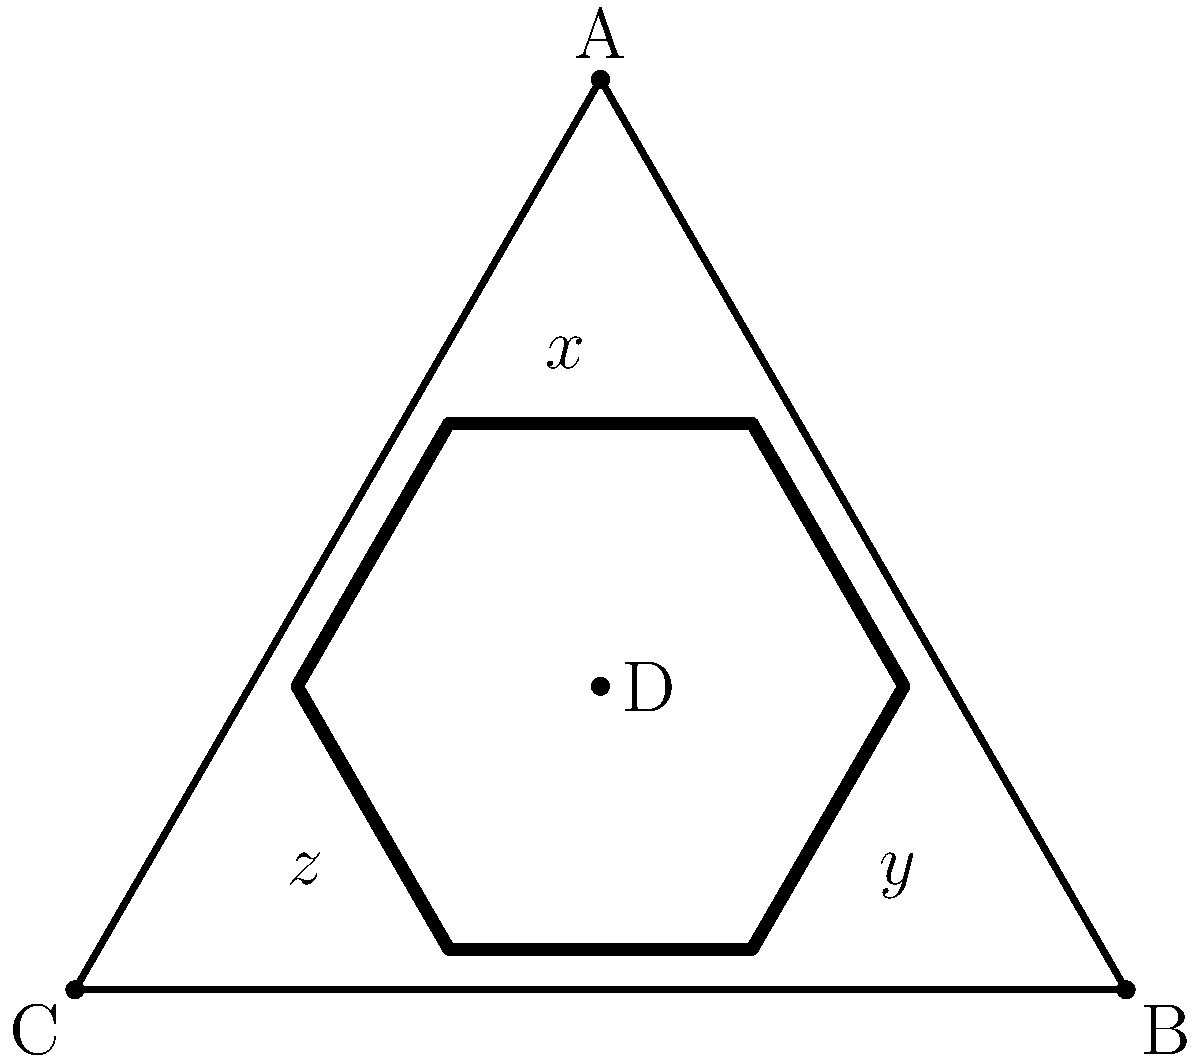In this Pictish symbol stone pattern, three lines intersect at point D, forming angles $x°$, $y°$, and $z°$. If $x = 2y$ and $z = 3y$, what is the value of $y$? To solve this problem, we'll follow these steps:

1) In any point where lines intersect, the sum of all angles around that point is always 360°. Therefore:

   $x + y + z = 360°$

2) We're given that $x = 2y$ and $z = 3y$. Let's substitute these into our equation:

   $2y + y + 3y = 360°$

3) Simplify by combining like terms:

   $6y = 360°$

4) Divide both sides by 6 to isolate $y$:

   $y = 360° ÷ 6 = 60°$

Thus, we've determined that $y = 60°$.
Answer: $60°$ 